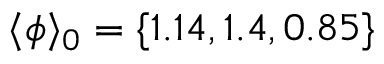<formula> <loc_0><loc_0><loc_500><loc_500>\langle \phi \rangle _ { 0 } = \{ 1 . 1 4 , 1 . 4 , 0 . 8 5 \}</formula> 